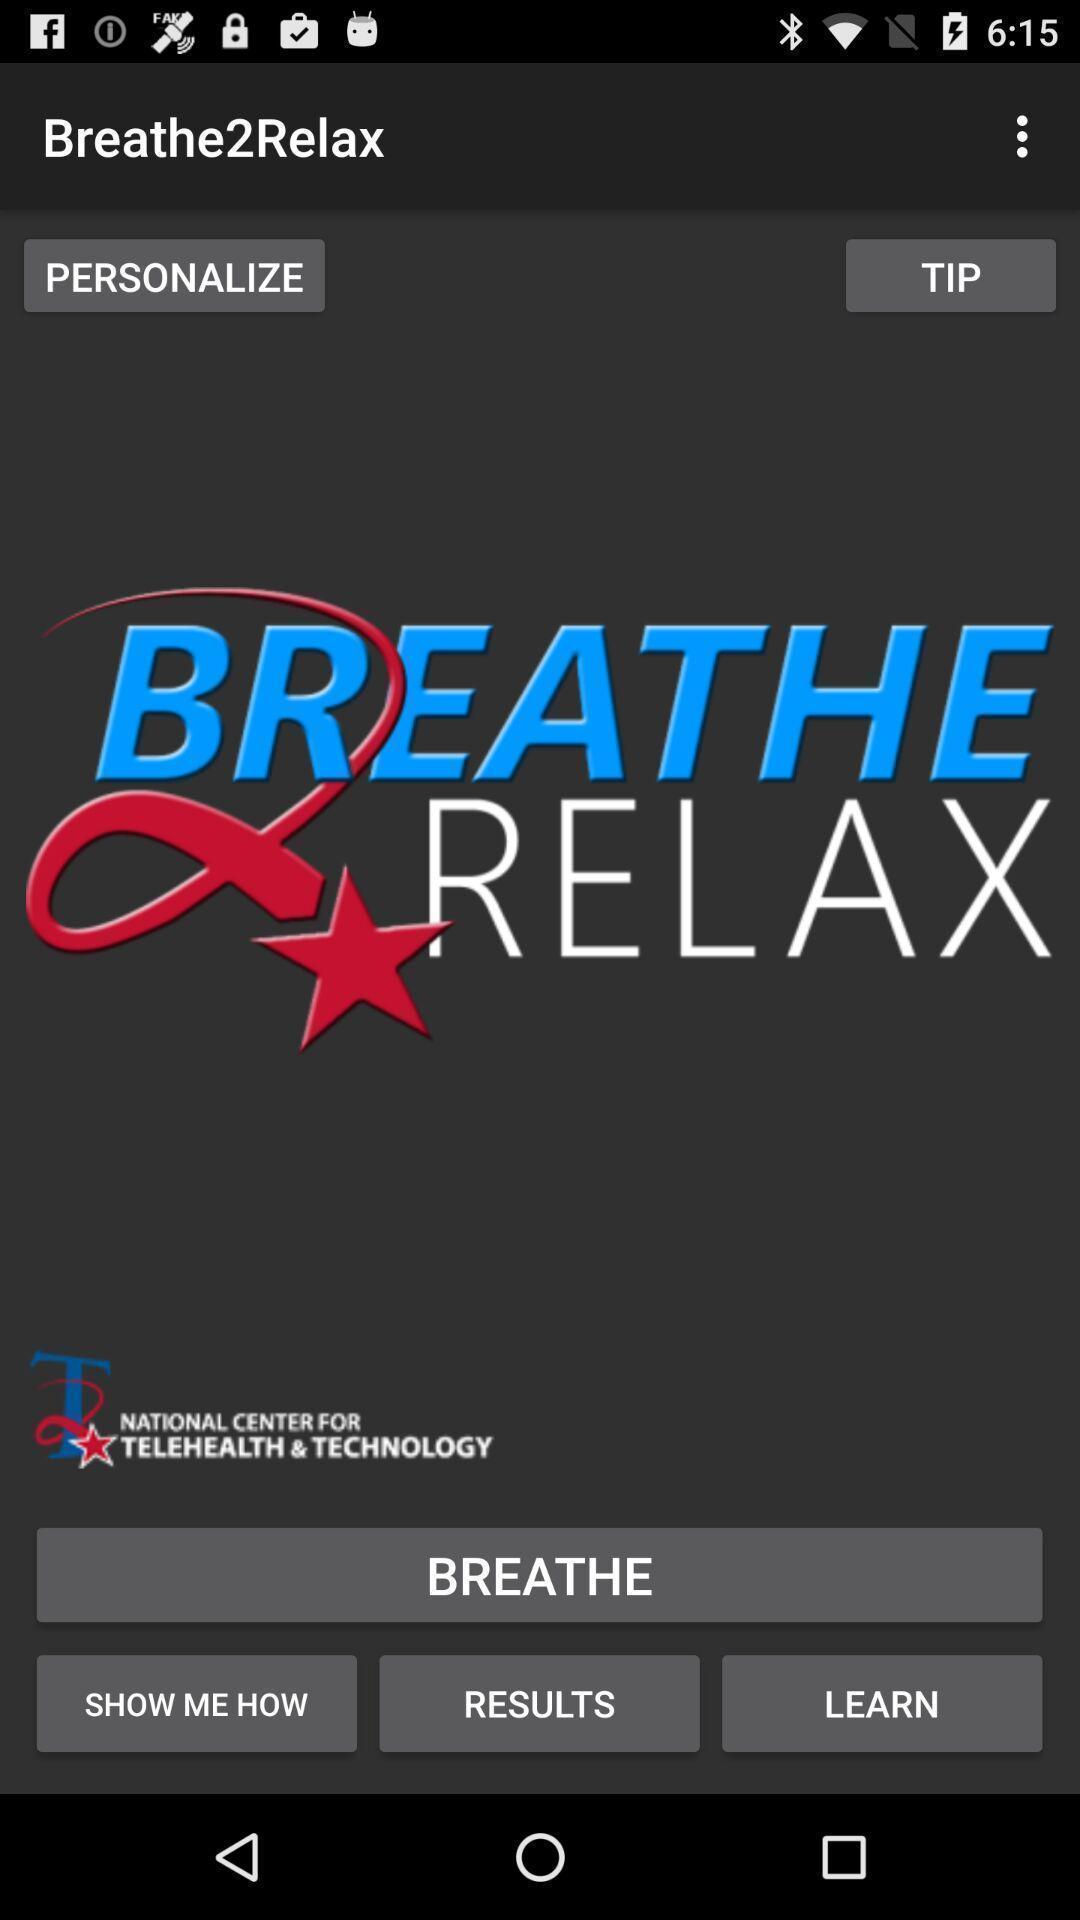Provide a description of this screenshot. Welcome page of a meditation app. 